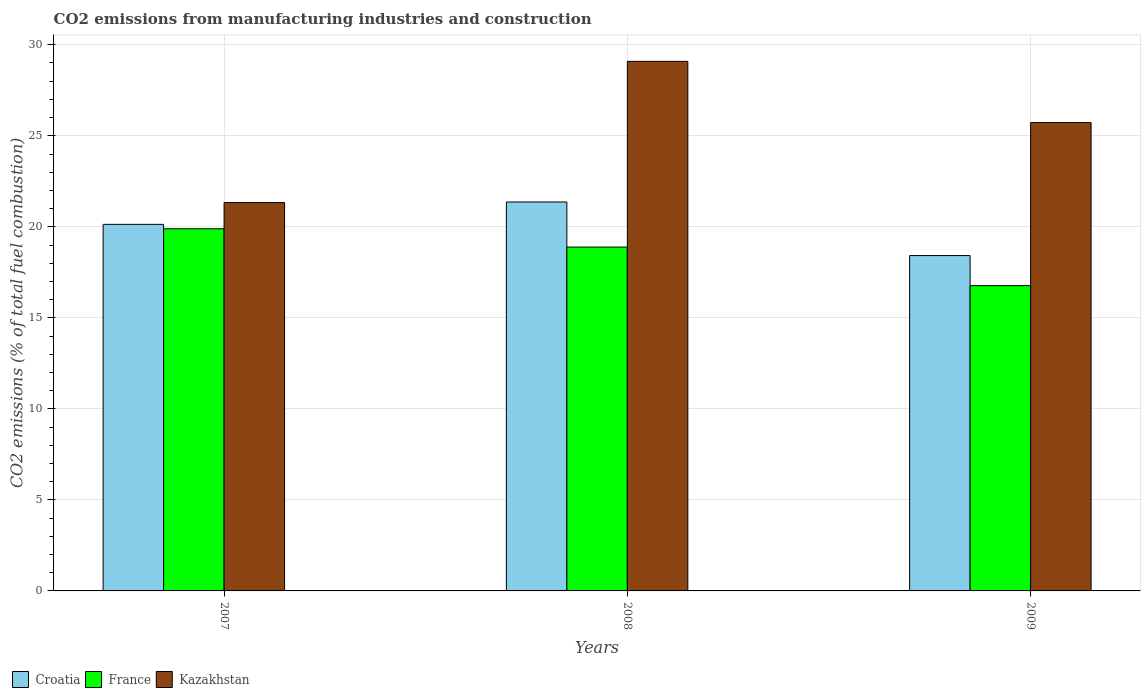How many different coloured bars are there?
Offer a terse response. 3. How many bars are there on the 2nd tick from the left?
Make the answer very short. 3. How many bars are there on the 2nd tick from the right?
Your answer should be very brief. 3. In how many cases, is the number of bars for a given year not equal to the number of legend labels?
Your response must be concise. 0. What is the amount of CO2 emitted in France in 2008?
Your answer should be very brief. 18.89. Across all years, what is the maximum amount of CO2 emitted in France?
Your response must be concise. 19.89. Across all years, what is the minimum amount of CO2 emitted in Croatia?
Ensure brevity in your answer.  18.42. In which year was the amount of CO2 emitted in Kazakhstan maximum?
Offer a terse response. 2008. What is the total amount of CO2 emitted in Kazakhstan in the graph?
Keep it short and to the point. 76.15. What is the difference between the amount of CO2 emitted in France in 2007 and that in 2009?
Provide a succinct answer. 3.12. What is the difference between the amount of CO2 emitted in Kazakhstan in 2008 and the amount of CO2 emitted in Croatia in 2009?
Keep it short and to the point. 10.67. What is the average amount of CO2 emitted in Croatia per year?
Your response must be concise. 19.97. In the year 2009, what is the difference between the amount of CO2 emitted in Kazakhstan and amount of CO2 emitted in France?
Provide a short and direct response. 8.95. In how many years, is the amount of CO2 emitted in France greater than 1 %?
Your answer should be very brief. 3. What is the ratio of the amount of CO2 emitted in Croatia in 2007 to that in 2009?
Give a very brief answer. 1.09. Is the amount of CO2 emitted in Croatia in 2008 less than that in 2009?
Your answer should be compact. No. What is the difference between the highest and the second highest amount of CO2 emitted in France?
Your answer should be very brief. 1.01. What is the difference between the highest and the lowest amount of CO2 emitted in Croatia?
Provide a succinct answer. 2.94. What does the 1st bar from the left in 2008 represents?
Offer a terse response. Croatia. What does the 1st bar from the right in 2007 represents?
Make the answer very short. Kazakhstan. Are all the bars in the graph horizontal?
Offer a very short reply. No. How many years are there in the graph?
Provide a short and direct response. 3. Does the graph contain any zero values?
Offer a very short reply. No. Does the graph contain grids?
Ensure brevity in your answer.  Yes. How many legend labels are there?
Provide a succinct answer. 3. How are the legend labels stacked?
Make the answer very short. Horizontal. What is the title of the graph?
Make the answer very short. CO2 emissions from manufacturing industries and construction. Does "Romania" appear as one of the legend labels in the graph?
Your answer should be very brief. No. What is the label or title of the Y-axis?
Keep it short and to the point. CO2 emissions (% of total fuel combustion). What is the CO2 emissions (% of total fuel combustion) in Croatia in 2007?
Your response must be concise. 20.14. What is the CO2 emissions (% of total fuel combustion) of France in 2007?
Give a very brief answer. 19.89. What is the CO2 emissions (% of total fuel combustion) of Kazakhstan in 2007?
Keep it short and to the point. 21.33. What is the CO2 emissions (% of total fuel combustion) of Croatia in 2008?
Your answer should be compact. 21.36. What is the CO2 emissions (% of total fuel combustion) of France in 2008?
Your answer should be compact. 18.89. What is the CO2 emissions (% of total fuel combustion) in Kazakhstan in 2008?
Your response must be concise. 29.09. What is the CO2 emissions (% of total fuel combustion) in Croatia in 2009?
Keep it short and to the point. 18.42. What is the CO2 emissions (% of total fuel combustion) in France in 2009?
Offer a very short reply. 16.77. What is the CO2 emissions (% of total fuel combustion) in Kazakhstan in 2009?
Your answer should be compact. 25.72. Across all years, what is the maximum CO2 emissions (% of total fuel combustion) of Croatia?
Your answer should be very brief. 21.36. Across all years, what is the maximum CO2 emissions (% of total fuel combustion) of France?
Provide a short and direct response. 19.89. Across all years, what is the maximum CO2 emissions (% of total fuel combustion) of Kazakhstan?
Your response must be concise. 29.09. Across all years, what is the minimum CO2 emissions (% of total fuel combustion) of Croatia?
Ensure brevity in your answer.  18.42. Across all years, what is the minimum CO2 emissions (% of total fuel combustion) of France?
Your answer should be compact. 16.77. Across all years, what is the minimum CO2 emissions (% of total fuel combustion) of Kazakhstan?
Ensure brevity in your answer.  21.33. What is the total CO2 emissions (% of total fuel combustion) of Croatia in the graph?
Your answer should be compact. 59.92. What is the total CO2 emissions (% of total fuel combustion) of France in the graph?
Provide a succinct answer. 55.55. What is the total CO2 emissions (% of total fuel combustion) of Kazakhstan in the graph?
Your answer should be compact. 76.15. What is the difference between the CO2 emissions (% of total fuel combustion) in Croatia in 2007 and that in 2008?
Your answer should be very brief. -1.23. What is the difference between the CO2 emissions (% of total fuel combustion) in France in 2007 and that in 2008?
Make the answer very short. 1.01. What is the difference between the CO2 emissions (% of total fuel combustion) of Kazakhstan in 2007 and that in 2008?
Give a very brief answer. -7.76. What is the difference between the CO2 emissions (% of total fuel combustion) in Croatia in 2007 and that in 2009?
Provide a succinct answer. 1.72. What is the difference between the CO2 emissions (% of total fuel combustion) in France in 2007 and that in 2009?
Your answer should be very brief. 3.12. What is the difference between the CO2 emissions (% of total fuel combustion) in Kazakhstan in 2007 and that in 2009?
Provide a short and direct response. -4.39. What is the difference between the CO2 emissions (% of total fuel combustion) in Croatia in 2008 and that in 2009?
Offer a terse response. 2.94. What is the difference between the CO2 emissions (% of total fuel combustion) of France in 2008 and that in 2009?
Ensure brevity in your answer.  2.12. What is the difference between the CO2 emissions (% of total fuel combustion) of Kazakhstan in 2008 and that in 2009?
Offer a very short reply. 3.37. What is the difference between the CO2 emissions (% of total fuel combustion) of Croatia in 2007 and the CO2 emissions (% of total fuel combustion) of France in 2008?
Give a very brief answer. 1.25. What is the difference between the CO2 emissions (% of total fuel combustion) in Croatia in 2007 and the CO2 emissions (% of total fuel combustion) in Kazakhstan in 2008?
Keep it short and to the point. -8.95. What is the difference between the CO2 emissions (% of total fuel combustion) in France in 2007 and the CO2 emissions (% of total fuel combustion) in Kazakhstan in 2008?
Give a very brief answer. -9.19. What is the difference between the CO2 emissions (% of total fuel combustion) in Croatia in 2007 and the CO2 emissions (% of total fuel combustion) in France in 2009?
Offer a very short reply. 3.37. What is the difference between the CO2 emissions (% of total fuel combustion) in Croatia in 2007 and the CO2 emissions (% of total fuel combustion) in Kazakhstan in 2009?
Ensure brevity in your answer.  -5.59. What is the difference between the CO2 emissions (% of total fuel combustion) of France in 2007 and the CO2 emissions (% of total fuel combustion) of Kazakhstan in 2009?
Your response must be concise. -5.83. What is the difference between the CO2 emissions (% of total fuel combustion) of Croatia in 2008 and the CO2 emissions (% of total fuel combustion) of France in 2009?
Keep it short and to the point. 4.59. What is the difference between the CO2 emissions (% of total fuel combustion) in Croatia in 2008 and the CO2 emissions (% of total fuel combustion) in Kazakhstan in 2009?
Provide a succinct answer. -4.36. What is the difference between the CO2 emissions (% of total fuel combustion) in France in 2008 and the CO2 emissions (% of total fuel combustion) in Kazakhstan in 2009?
Keep it short and to the point. -6.84. What is the average CO2 emissions (% of total fuel combustion) in Croatia per year?
Make the answer very short. 19.97. What is the average CO2 emissions (% of total fuel combustion) of France per year?
Ensure brevity in your answer.  18.52. What is the average CO2 emissions (% of total fuel combustion) of Kazakhstan per year?
Keep it short and to the point. 25.38. In the year 2007, what is the difference between the CO2 emissions (% of total fuel combustion) in Croatia and CO2 emissions (% of total fuel combustion) in France?
Give a very brief answer. 0.24. In the year 2007, what is the difference between the CO2 emissions (% of total fuel combustion) in Croatia and CO2 emissions (% of total fuel combustion) in Kazakhstan?
Offer a terse response. -1.2. In the year 2007, what is the difference between the CO2 emissions (% of total fuel combustion) of France and CO2 emissions (% of total fuel combustion) of Kazakhstan?
Provide a short and direct response. -1.44. In the year 2008, what is the difference between the CO2 emissions (% of total fuel combustion) in Croatia and CO2 emissions (% of total fuel combustion) in France?
Offer a terse response. 2.47. In the year 2008, what is the difference between the CO2 emissions (% of total fuel combustion) of Croatia and CO2 emissions (% of total fuel combustion) of Kazakhstan?
Your response must be concise. -7.73. In the year 2008, what is the difference between the CO2 emissions (% of total fuel combustion) in France and CO2 emissions (% of total fuel combustion) in Kazakhstan?
Give a very brief answer. -10.2. In the year 2009, what is the difference between the CO2 emissions (% of total fuel combustion) in Croatia and CO2 emissions (% of total fuel combustion) in France?
Make the answer very short. 1.65. In the year 2009, what is the difference between the CO2 emissions (% of total fuel combustion) in Croatia and CO2 emissions (% of total fuel combustion) in Kazakhstan?
Your answer should be compact. -7.3. In the year 2009, what is the difference between the CO2 emissions (% of total fuel combustion) in France and CO2 emissions (% of total fuel combustion) in Kazakhstan?
Offer a very short reply. -8.95. What is the ratio of the CO2 emissions (% of total fuel combustion) in Croatia in 2007 to that in 2008?
Provide a short and direct response. 0.94. What is the ratio of the CO2 emissions (% of total fuel combustion) in France in 2007 to that in 2008?
Your response must be concise. 1.05. What is the ratio of the CO2 emissions (% of total fuel combustion) of Kazakhstan in 2007 to that in 2008?
Give a very brief answer. 0.73. What is the ratio of the CO2 emissions (% of total fuel combustion) in Croatia in 2007 to that in 2009?
Give a very brief answer. 1.09. What is the ratio of the CO2 emissions (% of total fuel combustion) in France in 2007 to that in 2009?
Provide a short and direct response. 1.19. What is the ratio of the CO2 emissions (% of total fuel combustion) in Kazakhstan in 2007 to that in 2009?
Keep it short and to the point. 0.83. What is the ratio of the CO2 emissions (% of total fuel combustion) of Croatia in 2008 to that in 2009?
Provide a short and direct response. 1.16. What is the ratio of the CO2 emissions (% of total fuel combustion) in France in 2008 to that in 2009?
Make the answer very short. 1.13. What is the ratio of the CO2 emissions (% of total fuel combustion) in Kazakhstan in 2008 to that in 2009?
Your response must be concise. 1.13. What is the difference between the highest and the second highest CO2 emissions (% of total fuel combustion) of Croatia?
Your answer should be very brief. 1.23. What is the difference between the highest and the second highest CO2 emissions (% of total fuel combustion) in France?
Ensure brevity in your answer.  1.01. What is the difference between the highest and the second highest CO2 emissions (% of total fuel combustion) in Kazakhstan?
Make the answer very short. 3.37. What is the difference between the highest and the lowest CO2 emissions (% of total fuel combustion) of Croatia?
Your response must be concise. 2.94. What is the difference between the highest and the lowest CO2 emissions (% of total fuel combustion) in France?
Provide a succinct answer. 3.12. What is the difference between the highest and the lowest CO2 emissions (% of total fuel combustion) in Kazakhstan?
Ensure brevity in your answer.  7.76. 